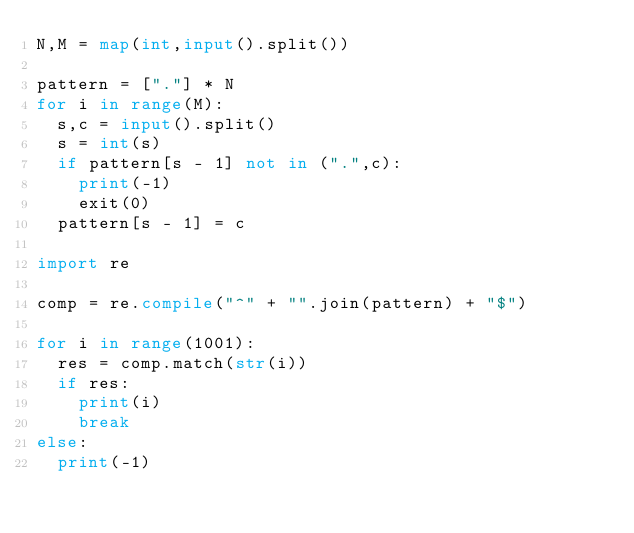Convert code to text. <code><loc_0><loc_0><loc_500><loc_500><_Python_>N,M = map(int,input().split())

pattern = ["."] * N
for i in range(M):
  s,c = input().split()
  s = int(s)
  if pattern[s - 1] not in (".",c):
    print(-1)
    exit(0)
  pattern[s - 1] = c

import re

comp = re.compile("^" + "".join(pattern) + "$")

for i in range(1001):
  res = comp.match(str(i))
  if res:
    print(i)
    break
else:
  print(-1)
</code> 